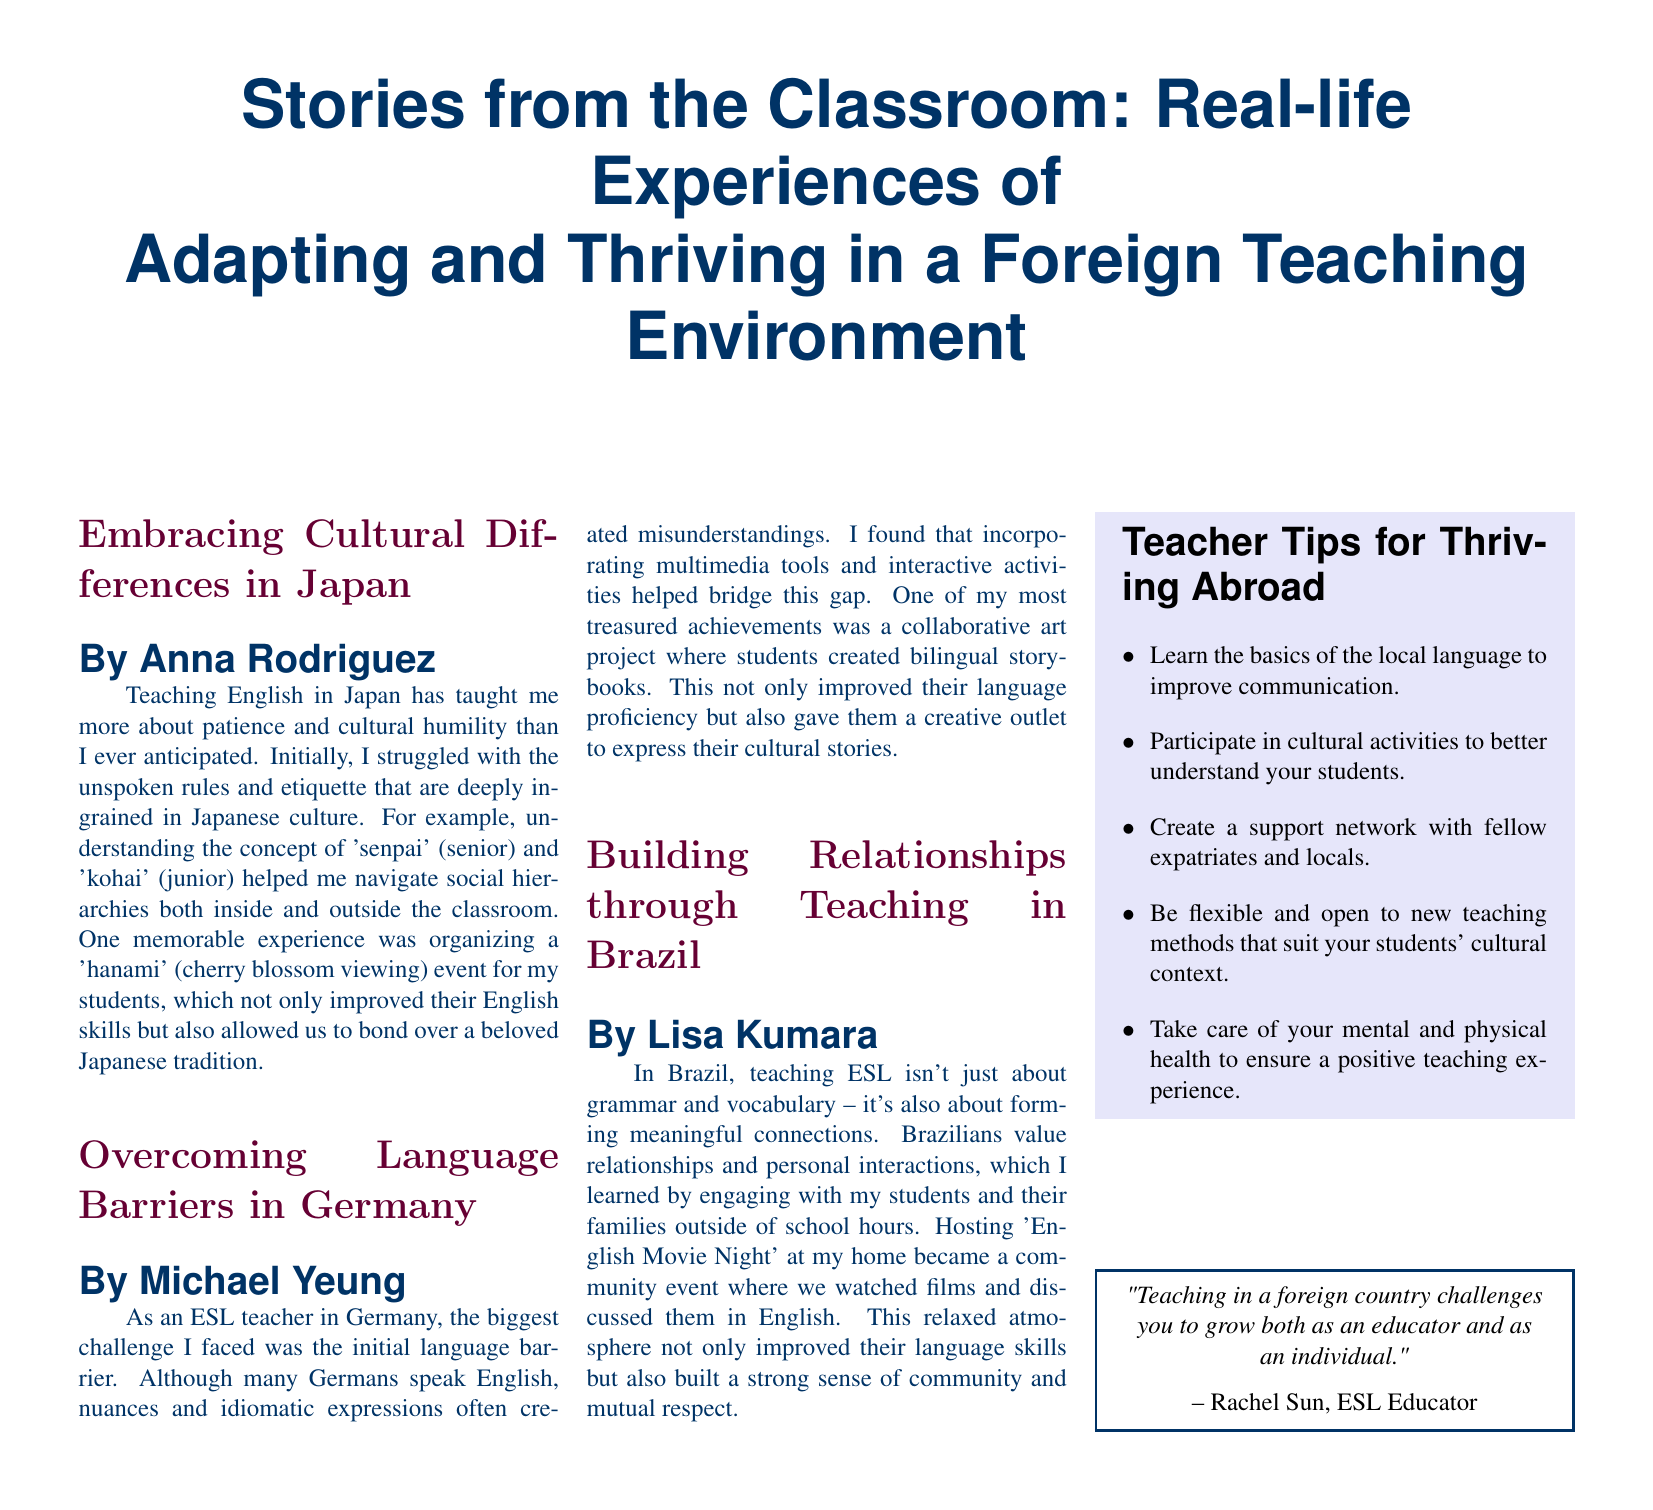What is the title of the document? The title of the document is prominently displayed at the top and introduces the main theme of the content.
Answer: Stories from the Classroom: Real-life Experiences of Adapting and Thriving in a Foreign Teaching Environment Who wrote the article about teaching in Japan? The document attributes each article to a specific author, and this question asks for the author of the Japan article.
Answer: Anna Rodriguez What cultural event did the teacher in Japan organize? The document mentions a specific cultural event that was significant for the students and teacher in Japan.
Answer: hanami In which country did Michael Yeung teach? The articles specify the countries where each teacher worked, and this question focuses on the author of an article.
Answer: Germany What activity did Lisa Kumara host to build community? The document describes a specific event that facilitated connection and language improvement among students.
Answer: English Movie Night How many tips are provided in the sidebar for thriving abroad? The sidebar lists a certain number of tips for teachers, addressing the specific content in that section.
Answer: Five What quote is included in the document? There is a notable quote from a specific educator that captures an overarching theme of the teaching experience abroad.
Answer: Teaching in a foreign country challenges you to grow both as an educator and as an individual What is the focus of the article written by Michael Yeung? The document provides insights into specific challenges faced by each teacher, and this question seeks the primary issue addressed by Yeung.
Answer: Overcoming Language Barriers What color is used for the sidebar background? The document describes specific colors used throughout, including that of the sidebar.
Answer: Light purple 